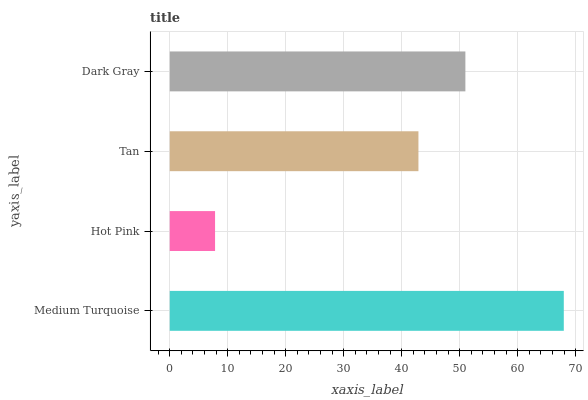Is Hot Pink the minimum?
Answer yes or no. Yes. Is Medium Turquoise the maximum?
Answer yes or no. Yes. Is Tan the minimum?
Answer yes or no. No. Is Tan the maximum?
Answer yes or no. No. Is Tan greater than Hot Pink?
Answer yes or no. Yes. Is Hot Pink less than Tan?
Answer yes or no. Yes. Is Hot Pink greater than Tan?
Answer yes or no. No. Is Tan less than Hot Pink?
Answer yes or no. No. Is Dark Gray the high median?
Answer yes or no. Yes. Is Tan the low median?
Answer yes or no. Yes. Is Medium Turquoise the high median?
Answer yes or no. No. Is Dark Gray the low median?
Answer yes or no. No. 